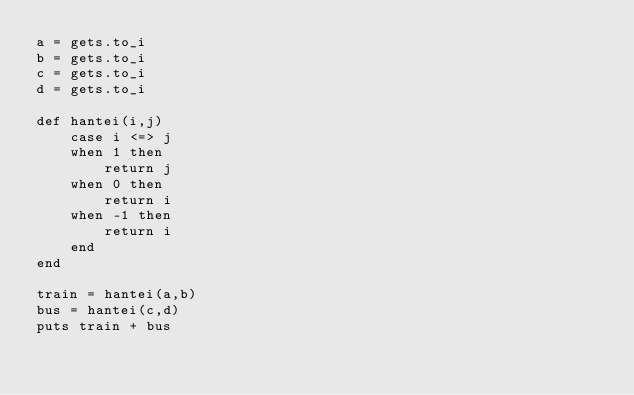Convert code to text. <code><loc_0><loc_0><loc_500><loc_500><_Ruby_>a = gets.to_i
b = gets.to_i
c = gets.to_i
d = gets.to_i

def hantei(i,j)
    case i <=> j
    when 1 then
        return j
    when 0 then
        return i
    when -1 then
        return i
    end
end

train = hantei(a,b)
bus = hantei(c,d)
puts train + bus</code> 